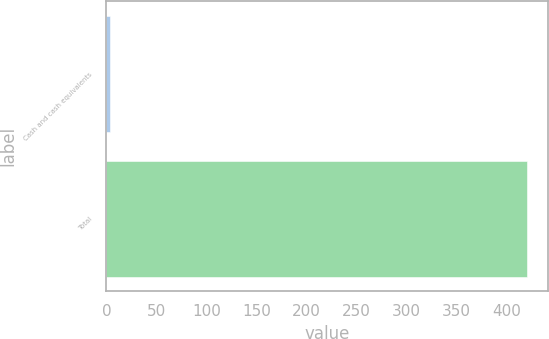Convert chart. <chart><loc_0><loc_0><loc_500><loc_500><bar_chart><fcel>Cash and cash equivalents<fcel>Total<nl><fcel>3.8<fcel>420.6<nl></chart> 